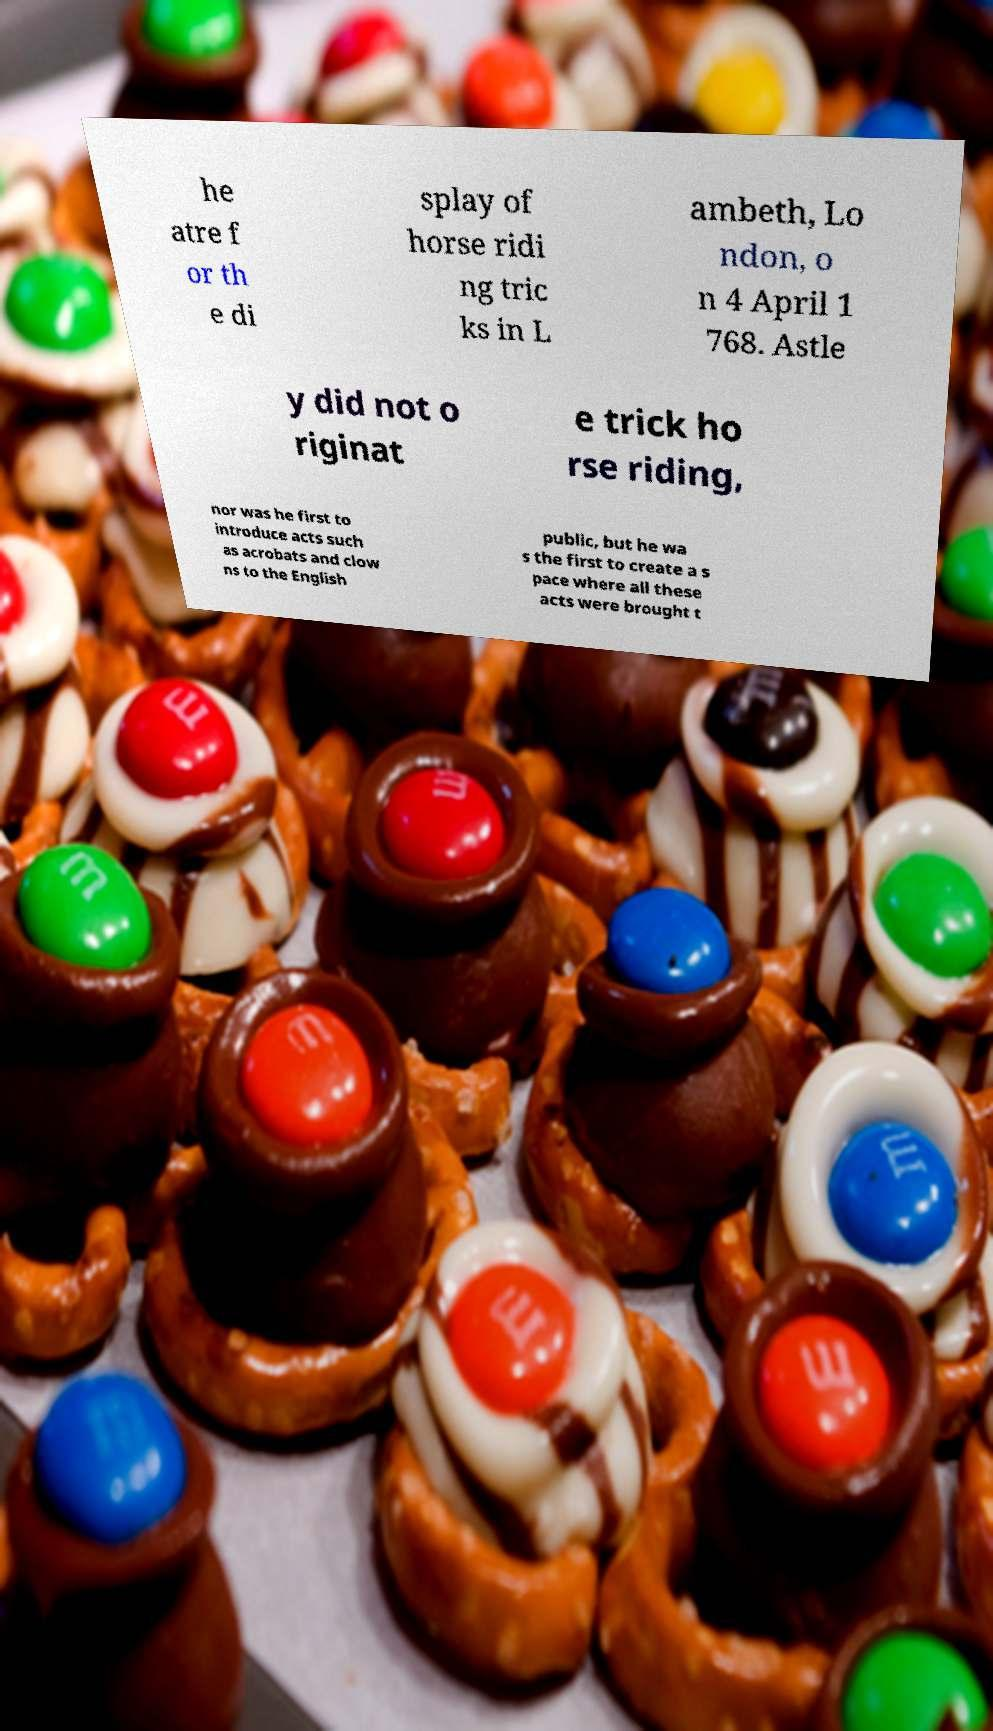Could you assist in decoding the text presented in this image and type it out clearly? he atre f or th e di splay of horse ridi ng tric ks in L ambeth, Lo ndon, o n 4 April 1 768. Astle y did not o riginat e trick ho rse riding, nor was he first to introduce acts such as acrobats and clow ns to the English public, but he wa s the first to create a s pace where all these acts were brought t 